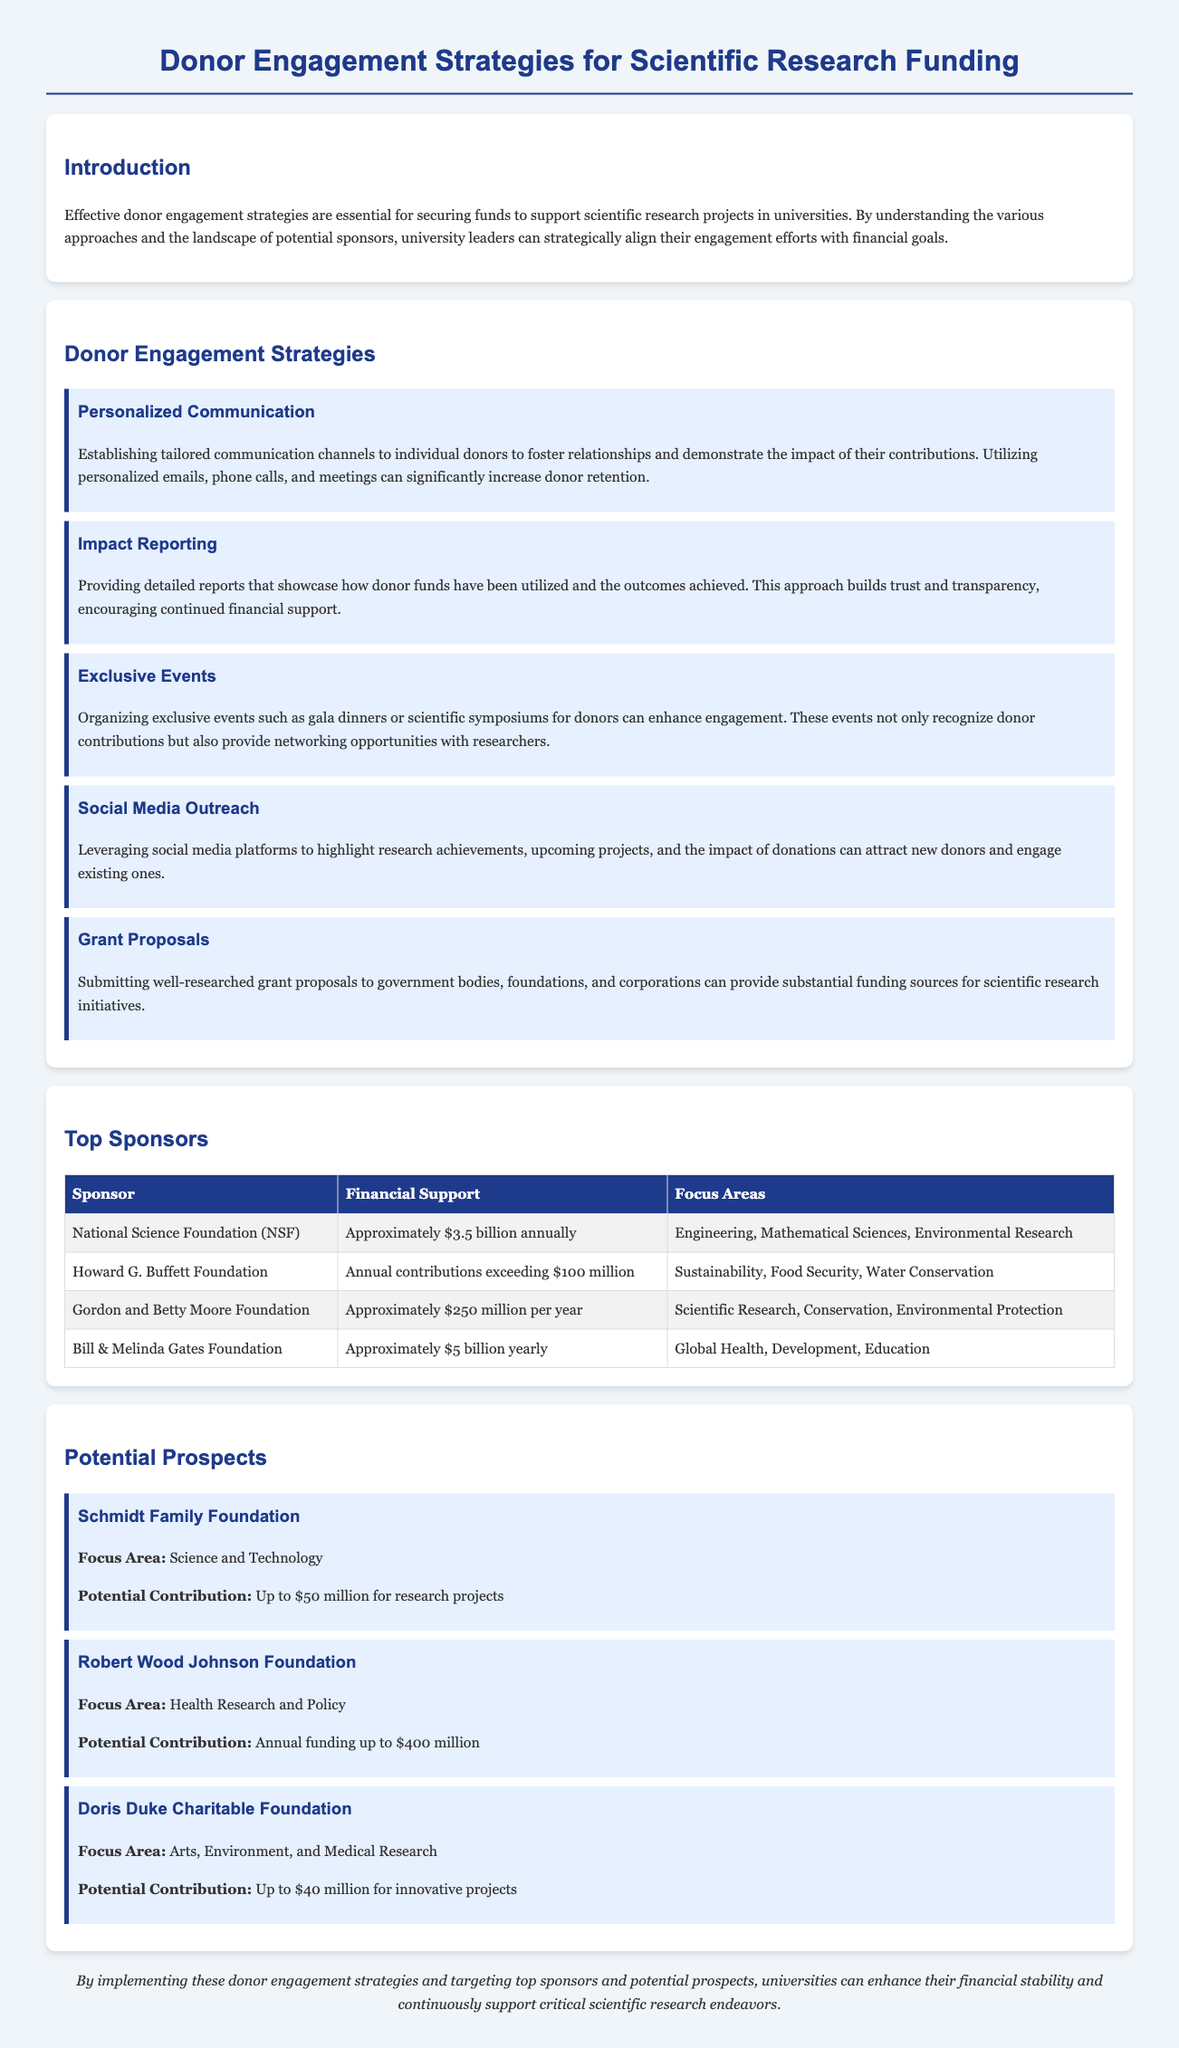What is the total annual contribution from the Bill & Melinda Gates Foundation? The annual contribution from the Bill & Melinda Gates Foundation is mentioned as approximately $5 billion yearly.
Answer: Approximately $5 billion yearly What is one focus area of the National Science Foundation? The focus areas of the National Science Foundation are listed, and one of them is Engineering.
Answer: Engineering Which prospect has a potential contribution of up to $50 million? The Schmidt Family Foundation is listed with a potential contribution of up to $50 million for research projects.
Answer: Schmidt Family Foundation What strategy involves using social media to engage donors? The document details strategies, and the one involving social media is titled "Social Media Outreach."
Answer: Social Media Outreach How much annual funding is available from the Robert Wood Johnson Foundation? The Robert Wood Johnson Foundation's potential contribution is stated as annual funding up to $400 million.
Answer: Up to $400 million What is a common element among the donor engagement strategies? The strategies include the use of personalized communication, impact reporting, and organizing exclusive events, suggesting a focus on relationship building.
Answer: Relationship building Which foundation focuses on Arts, Environment, and Medical Research? The Doris Duke Charitable Foundation is specified as focusing on Arts, Environment, and Medical Research.
Answer: Doris Duke Charitable Foundation How many top sponsors are listed in the document? The document lists a total of four top sponsors.
Answer: Four 